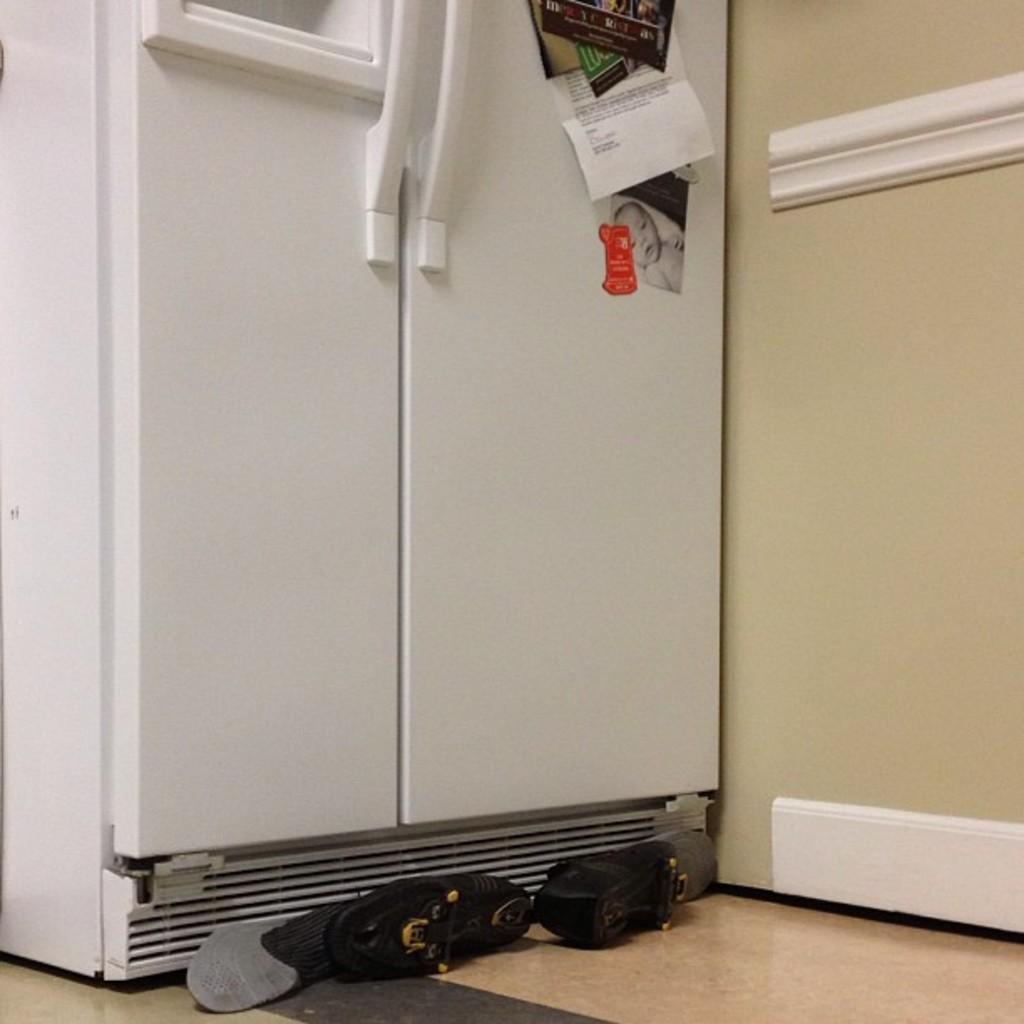What is the main object in the image? There is a door in the image. What is attached to the door? Posters are attached to the door. What can be seen on the floor near the door? There is footwear visible in the image. What is on the right side of the image? There is a wall on the right side of the image. How many women are present in the image? There is no mention of women in the image, so we cannot determine their presence or number. 